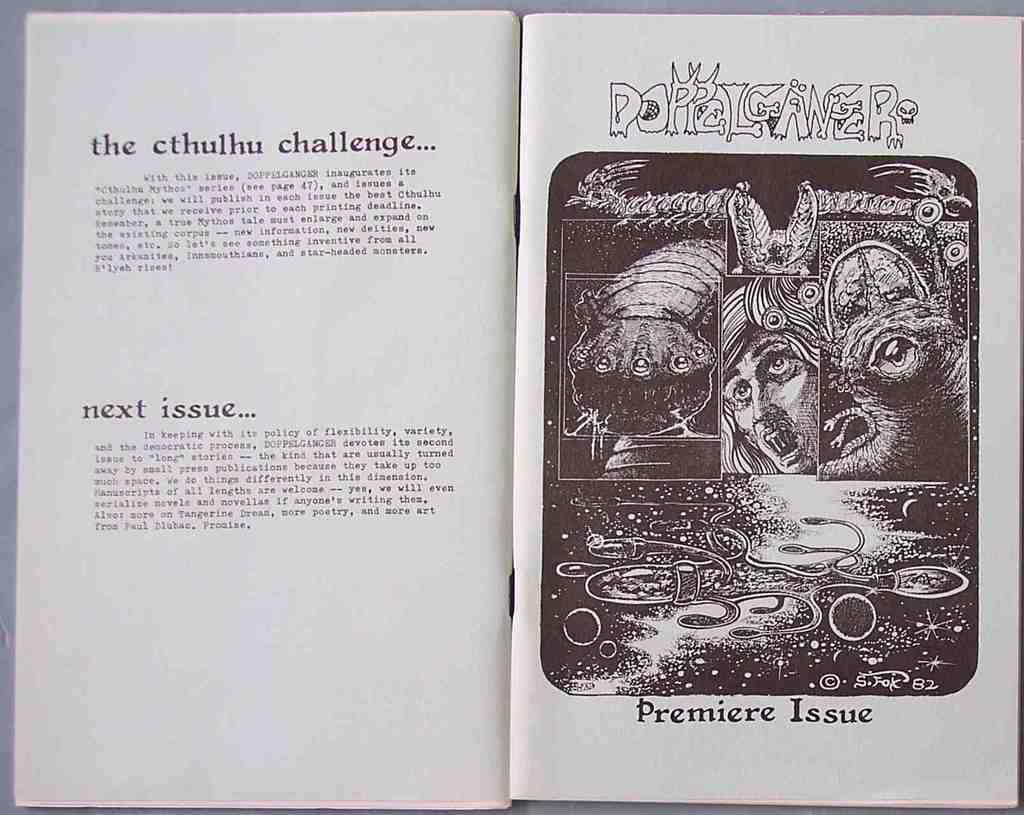<image>
Share a concise interpretation of the image provided. A book is opened to a page that says Premiere Issue with an illustration of monsters. 